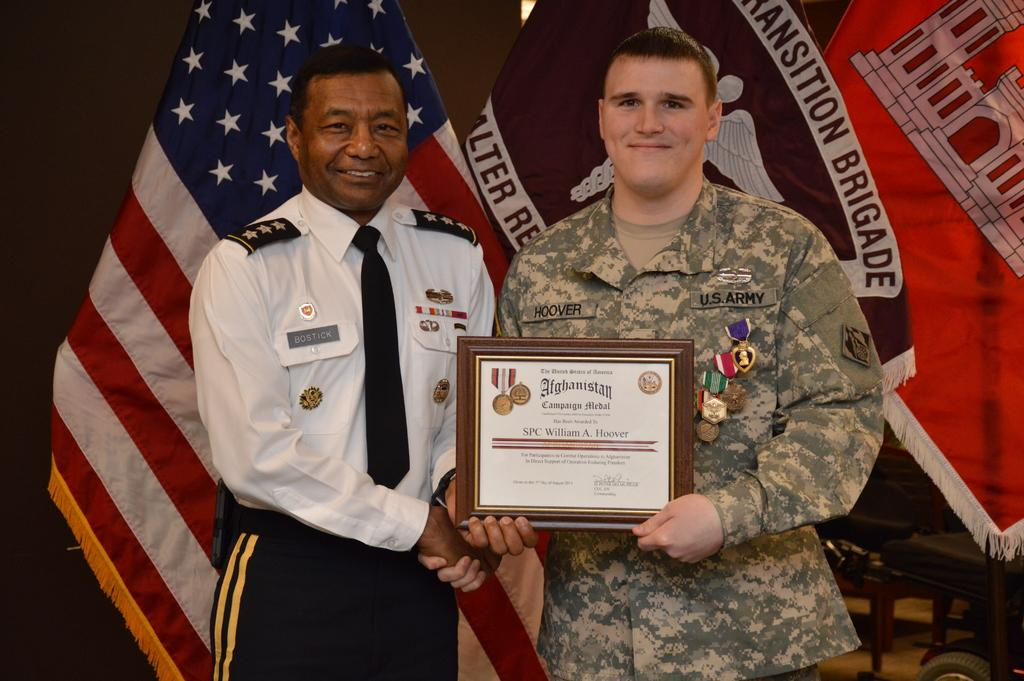How many people are in the image? There are two people in the image. What are the people wearing? Both people are in uniform. What are the people doing in the image? They are posing for a picture and shaking hands. What are they holding in the image? They are holding an award. What type of linen is visible in the image? There is no linen present in the image. What kind of shoe is the person on the left wearing? There is no shoe visible in the image, as both people are in uniform and their feet are not shown. 